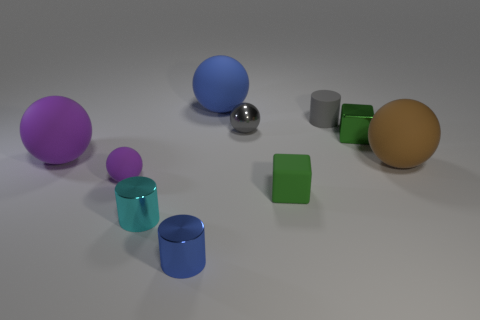Subtract all metallic cylinders. How many cylinders are left? 1 Subtract 1 cylinders. How many cylinders are left? 2 Subtract all purple balls. How many balls are left? 3 Subtract all cylinders. How many objects are left? 7 Subtract all gray balls. Subtract all green blocks. How many balls are left? 4 Subtract all tiny matte blocks. Subtract all blue things. How many objects are left? 7 Add 9 blue cylinders. How many blue cylinders are left? 10 Add 8 large cyan matte objects. How many large cyan matte objects exist? 8 Subtract 2 purple spheres. How many objects are left? 8 